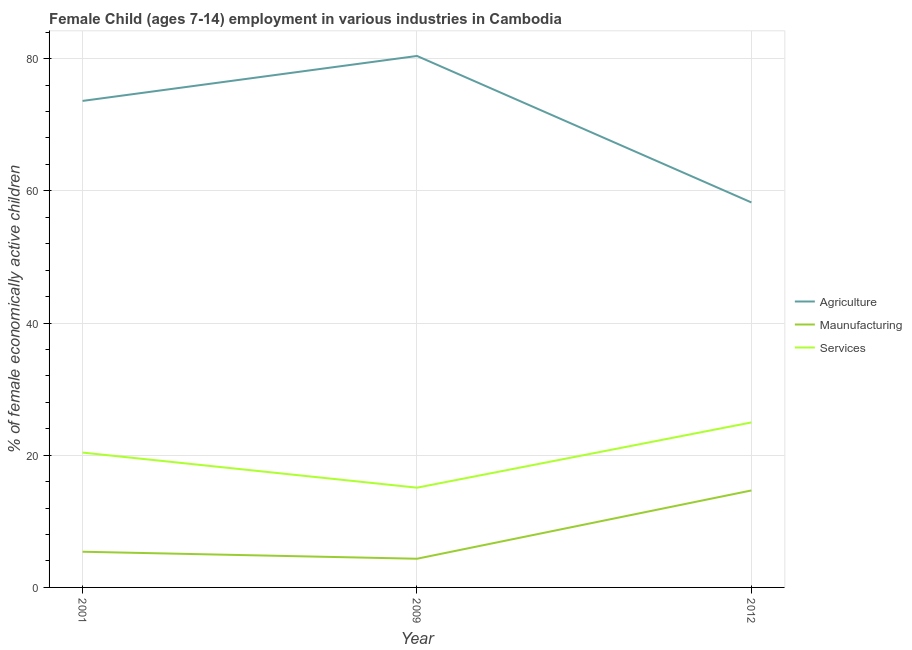Does the line corresponding to percentage of economically active children in services intersect with the line corresponding to percentage of economically active children in agriculture?
Your answer should be compact. No. Is the number of lines equal to the number of legend labels?
Ensure brevity in your answer.  Yes. What is the percentage of economically active children in services in 2001?
Offer a terse response. 20.4. Across all years, what is the maximum percentage of economically active children in agriculture?
Provide a short and direct response. 80.4. Across all years, what is the minimum percentage of economically active children in agriculture?
Ensure brevity in your answer.  58.24. In which year was the percentage of economically active children in agriculture maximum?
Your answer should be very brief. 2009. In which year was the percentage of economically active children in agriculture minimum?
Your answer should be very brief. 2012. What is the total percentage of economically active children in services in the graph?
Ensure brevity in your answer.  60.45. What is the difference between the percentage of economically active children in services in 2009 and that in 2012?
Your answer should be very brief. -9.87. What is the difference between the percentage of economically active children in agriculture in 2001 and the percentage of economically active children in manufacturing in 2009?
Offer a terse response. 69.26. What is the average percentage of economically active children in agriculture per year?
Provide a short and direct response. 70.75. In the year 2012, what is the difference between the percentage of economically active children in agriculture and percentage of economically active children in services?
Your response must be concise. 33.28. What is the ratio of the percentage of economically active children in services in 2001 to that in 2009?
Your answer should be very brief. 1.35. Is the percentage of economically active children in agriculture in 2009 less than that in 2012?
Offer a very short reply. No. Is the difference between the percentage of economically active children in services in 2001 and 2009 greater than the difference between the percentage of economically active children in agriculture in 2001 and 2009?
Offer a terse response. Yes. What is the difference between the highest and the second highest percentage of economically active children in services?
Your answer should be very brief. 4.56. What is the difference between the highest and the lowest percentage of economically active children in agriculture?
Your answer should be very brief. 22.16. In how many years, is the percentage of economically active children in manufacturing greater than the average percentage of economically active children in manufacturing taken over all years?
Ensure brevity in your answer.  1. How many years are there in the graph?
Offer a terse response. 3. What is the difference between two consecutive major ticks on the Y-axis?
Your answer should be very brief. 20. Does the graph contain any zero values?
Make the answer very short. No. Does the graph contain grids?
Your answer should be very brief. Yes. Where does the legend appear in the graph?
Provide a succinct answer. Center right. How are the legend labels stacked?
Your response must be concise. Vertical. What is the title of the graph?
Your response must be concise. Female Child (ages 7-14) employment in various industries in Cambodia. Does "Financial account" appear as one of the legend labels in the graph?
Offer a terse response. No. What is the label or title of the Y-axis?
Make the answer very short. % of female economically active children. What is the % of female economically active children in Agriculture in 2001?
Offer a very short reply. 73.6. What is the % of female economically active children of Maunufacturing in 2001?
Your answer should be very brief. 5.4. What is the % of female economically active children of Services in 2001?
Make the answer very short. 20.4. What is the % of female economically active children of Agriculture in 2009?
Make the answer very short. 80.4. What is the % of female economically active children in Maunufacturing in 2009?
Your answer should be compact. 4.34. What is the % of female economically active children of Services in 2009?
Your answer should be very brief. 15.09. What is the % of female economically active children of Agriculture in 2012?
Ensure brevity in your answer.  58.24. What is the % of female economically active children in Maunufacturing in 2012?
Ensure brevity in your answer.  14.67. What is the % of female economically active children in Services in 2012?
Offer a very short reply. 24.96. Across all years, what is the maximum % of female economically active children in Agriculture?
Make the answer very short. 80.4. Across all years, what is the maximum % of female economically active children of Maunufacturing?
Give a very brief answer. 14.67. Across all years, what is the maximum % of female economically active children of Services?
Keep it short and to the point. 24.96. Across all years, what is the minimum % of female economically active children of Agriculture?
Keep it short and to the point. 58.24. Across all years, what is the minimum % of female economically active children in Maunufacturing?
Offer a very short reply. 4.34. Across all years, what is the minimum % of female economically active children in Services?
Ensure brevity in your answer.  15.09. What is the total % of female economically active children of Agriculture in the graph?
Provide a short and direct response. 212.24. What is the total % of female economically active children in Maunufacturing in the graph?
Offer a terse response. 24.41. What is the total % of female economically active children in Services in the graph?
Provide a succinct answer. 60.45. What is the difference between the % of female economically active children of Agriculture in 2001 and that in 2009?
Offer a very short reply. -6.8. What is the difference between the % of female economically active children of Maunufacturing in 2001 and that in 2009?
Offer a very short reply. 1.06. What is the difference between the % of female economically active children of Services in 2001 and that in 2009?
Ensure brevity in your answer.  5.31. What is the difference between the % of female economically active children of Agriculture in 2001 and that in 2012?
Offer a very short reply. 15.36. What is the difference between the % of female economically active children of Maunufacturing in 2001 and that in 2012?
Give a very brief answer. -9.27. What is the difference between the % of female economically active children of Services in 2001 and that in 2012?
Your answer should be very brief. -4.56. What is the difference between the % of female economically active children of Agriculture in 2009 and that in 2012?
Your response must be concise. 22.16. What is the difference between the % of female economically active children in Maunufacturing in 2009 and that in 2012?
Your response must be concise. -10.33. What is the difference between the % of female economically active children of Services in 2009 and that in 2012?
Make the answer very short. -9.87. What is the difference between the % of female economically active children of Agriculture in 2001 and the % of female economically active children of Maunufacturing in 2009?
Offer a very short reply. 69.26. What is the difference between the % of female economically active children of Agriculture in 2001 and the % of female economically active children of Services in 2009?
Your response must be concise. 58.51. What is the difference between the % of female economically active children of Maunufacturing in 2001 and the % of female economically active children of Services in 2009?
Provide a succinct answer. -9.69. What is the difference between the % of female economically active children of Agriculture in 2001 and the % of female economically active children of Maunufacturing in 2012?
Ensure brevity in your answer.  58.93. What is the difference between the % of female economically active children in Agriculture in 2001 and the % of female economically active children in Services in 2012?
Your answer should be compact. 48.64. What is the difference between the % of female economically active children in Maunufacturing in 2001 and the % of female economically active children in Services in 2012?
Your answer should be very brief. -19.56. What is the difference between the % of female economically active children of Agriculture in 2009 and the % of female economically active children of Maunufacturing in 2012?
Ensure brevity in your answer.  65.73. What is the difference between the % of female economically active children of Agriculture in 2009 and the % of female economically active children of Services in 2012?
Keep it short and to the point. 55.44. What is the difference between the % of female economically active children in Maunufacturing in 2009 and the % of female economically active children in Services in 2012?
Give a very brief answer. -20.62. What is the average % of female economically active children in Agriculture per year?
Make the answer very short. 70.75. What is the average % of female economically active children of Maunufacturing per year?
Give a very brief answer. 8.14. What is the average % of female economically active children in Services per year?
Ensure brevity in your answer.  20.15. In the year 2001, what is the difference between the % of female economically active children of Agriculture and % of female economically active children of Maunufacturing?
Keep it short and to the point. 68.2. In the year 2001, what is the difference between the % of female economically active children of Agriculture and % of female economically active children of Services?
Provide a short and direct response. 53.2. In the year 2001, what is the difference between the % of female economically active children of Maunufacturing and % of female economically active children of Services?
Your response must be concise. -15. In the year 2009, what is the difference between the % of female economically active children in Agriculture and % of female economically active children in Maunufacturing?
Make the answer very short. 76.06. In the year 2009, what is the difference between the % of female economically active children in Agriculture and % of female economically active children in Services?
Your answer should be compact. 65.31. In the year 2009, what is the difference between the % of female economically active children of Maunufacturing and % of female economically active children of Services?
Provide a short and direct response. -10.75. In the year 2012, what is the difference between the % of female economically active children in Agriculture and % of female economically active children in Maunufacturing?
Give a very brief answer. 43.57. In the year 2012, what is the difference between the % of female economically active children in Agriculture and % of female economically active children in Services?
Ensure brevity in your answer.  33.28. In the year 2012, what is the difference between the % of female economically active children in Maunufacturing and % of female economically active children in Services?
Provide a succinct answer. -10.29. What is the ratio of the % of female economically active children in Agriculture in 2001 to that in 2009?
Your response must be concise. 0.92. What is the ratio of the % of female economically active children of Maunufacturing in 2001 to that in 2009?
Give a very brief answer. 1.24. What is the ratio of the % of female economically active children of Services in 2001 to that in 2009?
Provide a succinct answer. 1.35. What is the ratio of the % of female economically active children of Agriculture in 2001 to that in 2012?
Keep it short and to the point. 1.26. What is the ratio of the % of female economically active children of Maunufacturing in 2001 to that in 2012?
Your answer should be compact. 0.37. What is the ratio of the % of female economically active children of Services in 2001 to that in 2012?
Offer a very short reply. 0.82. What is the ratio of the % of female economically active children in Agriculture in 2009 to that in 2012?
Provide a succinct answer. 1.38. What is the ratio of the % of female economically active children in Maunufacturing in 2009 to that in 2012?
Make the answer very short. 0.3. What is the ratio of the % of female economically active children of Services in 2009 to that in 2012?
Provide a succinct answer. 0.6. What is the difference between the highest and the second highest % of female economically active children of Agriculture?
Keep it short and to the point. 6.8. What is the difference between the highest and the second highest % of female economically active children of Maunufacturing?
Provide a short and direct response. 9.27. What is the difference between the highest and the second highest % of female economically active children of Services?
Make the answer very short. 4.56. What is the difference between the highest and the lowest % of female economically active children of Agriculture?
Offer a very short reply. 22.16. What is the difference between the highest and the lowest % of female economically active children in Maunufacturing?
Provide a short and direct response. 10.33. What is the difference between the highest and the lowest % of female economically active children of Services?
Your answer should be very brief. 9.87. 